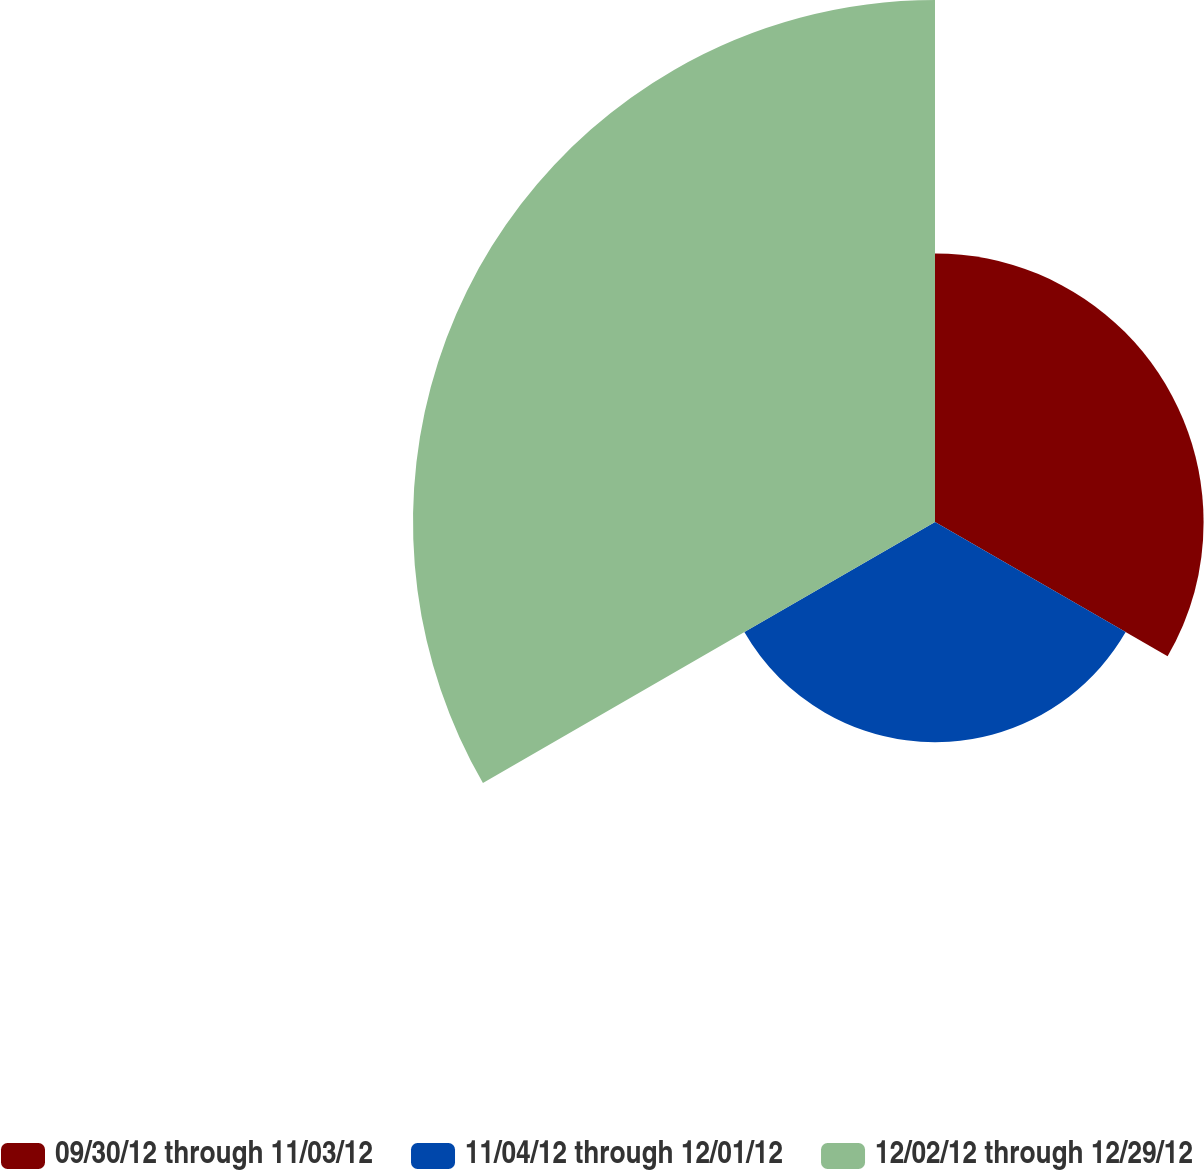Convert chart to OTSL. <chart><loc_0><loc_0><loc_500><loc_500><pie_chart><fcel>09/30/12 through 11/03/12<fcel>11/04/12 through 12/01/12<fcel>12/02/12 through 12/29/12<nl><fcel>26.57%<fcel>21.78%<fcel>51.64%<nl></chart> 